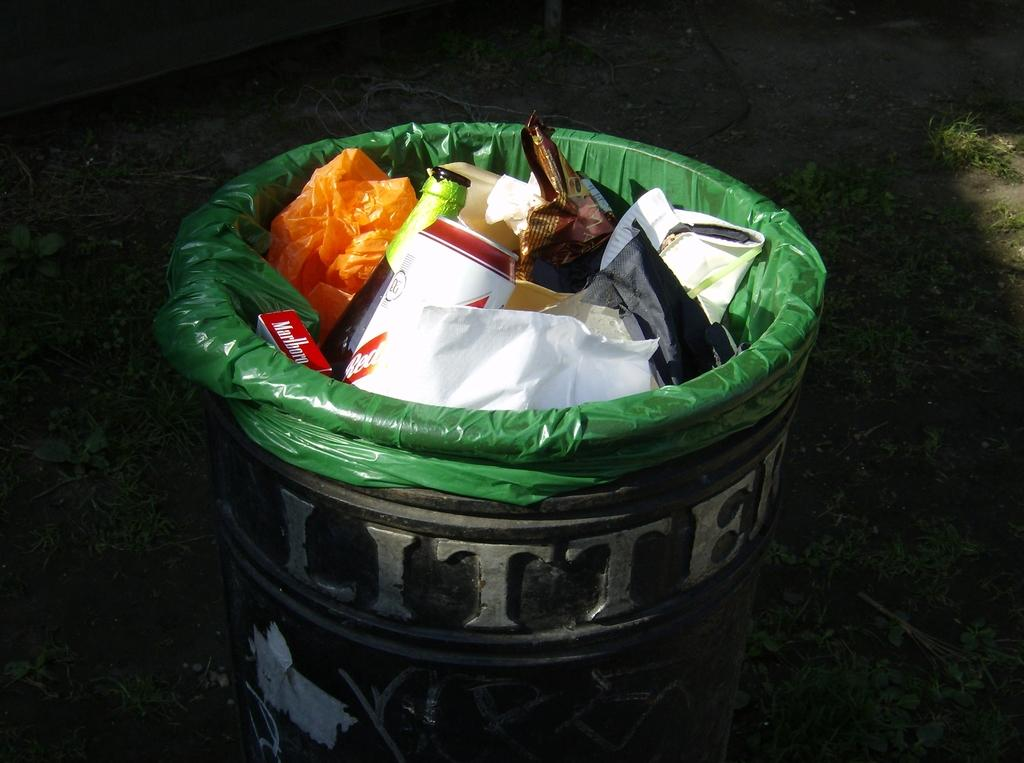<image>
Describe the image concisely. Litter trash can with a green bag with trash on the inside 